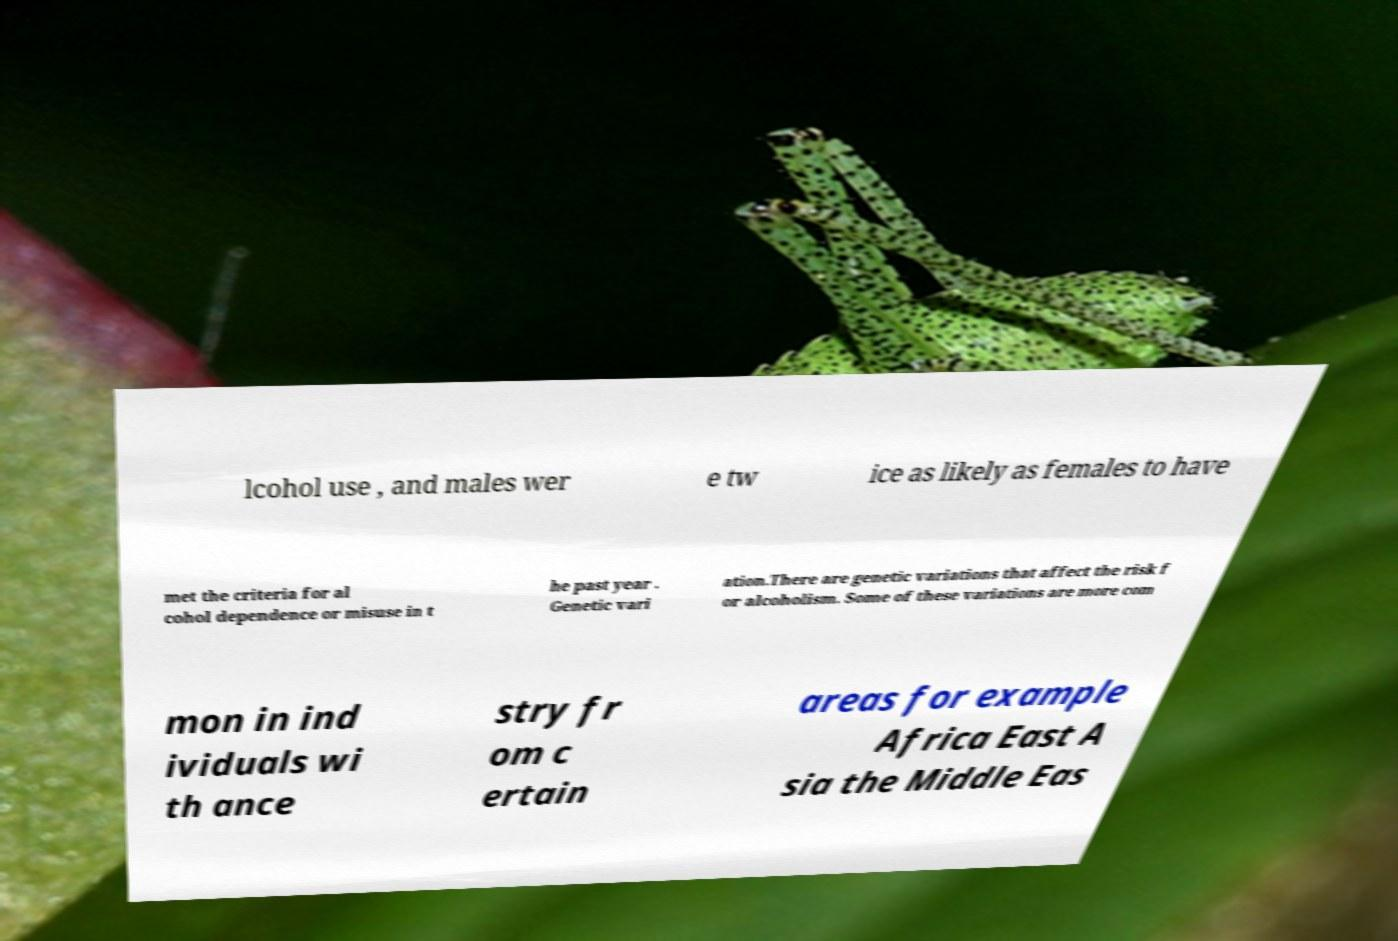Please identify and transcribe the text found in this image. lcohol use , and males wer e tw ice as likely as females to have met the criteria for al cohol dependence or misuse in t he past year . Genetic vari ation.There are genetic variations that affect the risk f or alcoholism. Some of these variations are more com mon in ind ividuals wi th ance stry fr om c ertain areas for example Africa East A sia the Middle Eas 